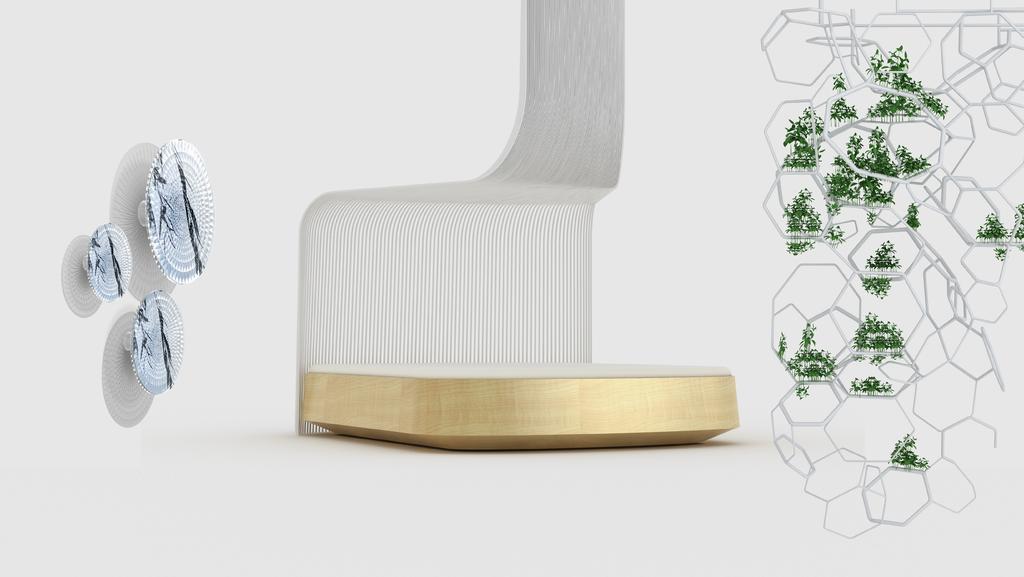Can you describe this image briefly? This is an edited image, in this picture we can see red, leaves and objects. In the background of the image it is white. 